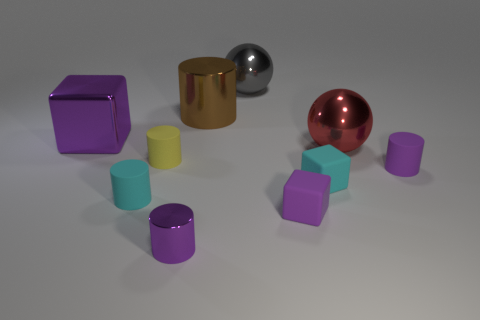Are there any small cylinders?
Provide a succinct answer. Yes. There is a matte cylinder that is right of the metal sphere that is left of the big red ball; are there any small yellow matte cylinders in front of it?
Offer a very short reply. No. There is a big red object; is its shape the same as the purple rubber thing behind the small purple matte block?
Keep it short and to the point. No. The metal ball that is left of the red object that is in front of the metallic cylinder that is behind the large red ball is what color?
Offer a terse response. Gray. What number of objects are either purple cylinders that are to the right of the big brown shiny cylinder or tiny rubber cylinders to the left of the large red shiny ball?
Make the answer very short. 3. What number of other things are the same color as the tiny metallic thing?
Give a very brief answer. 3. Is the shape of the metal thing that is left of the yellow matte object the same as  the yellow thing?
Provide a short and direct response. No. Is the number of big purple metallic blocks that are left of the big purple shiny object less than the number of cyan cylinders?
Provide a short and direct response. Yes. Is there a sphere that has the same material as the tiny cyan cylinder?
Your response must be concise. No. There is a red ball that is the same size as the gray metal object; what material is it?
Offer a very short reply. Metal. 